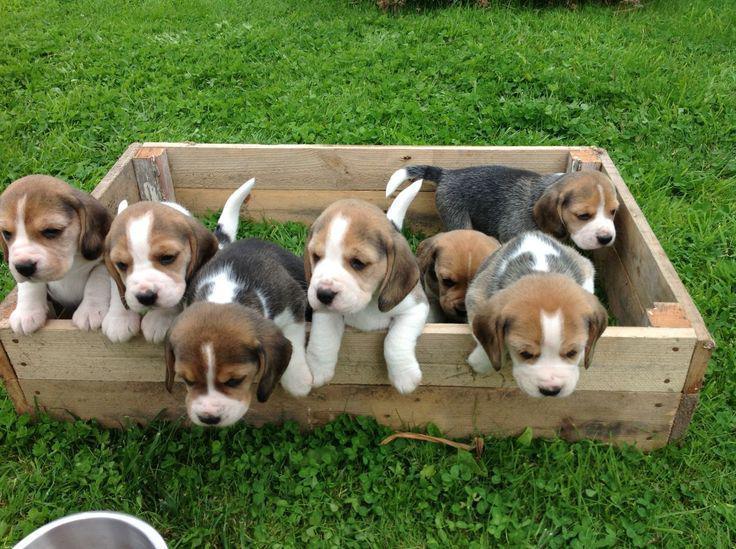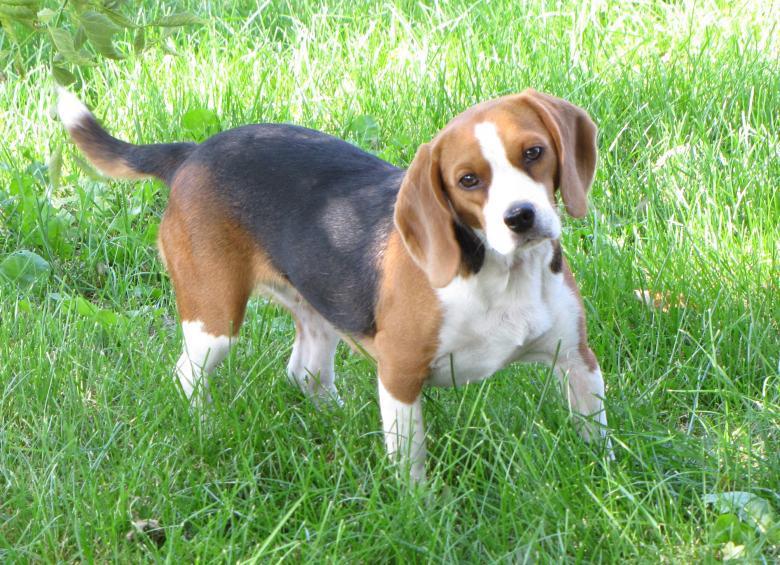The first image is the image on the left, the second image is the image on the right. Analyze the images presented: Is the assertion "There are no more than 3 puppies in total." valid? Answer yes or no. No. The first image is the image on the left, the second image is the image on the right. Evaluate the accuracy of this statement regarding the images: "There are more dogs in the right image than in the left image.". Is it true? Answer yes or no. No. 